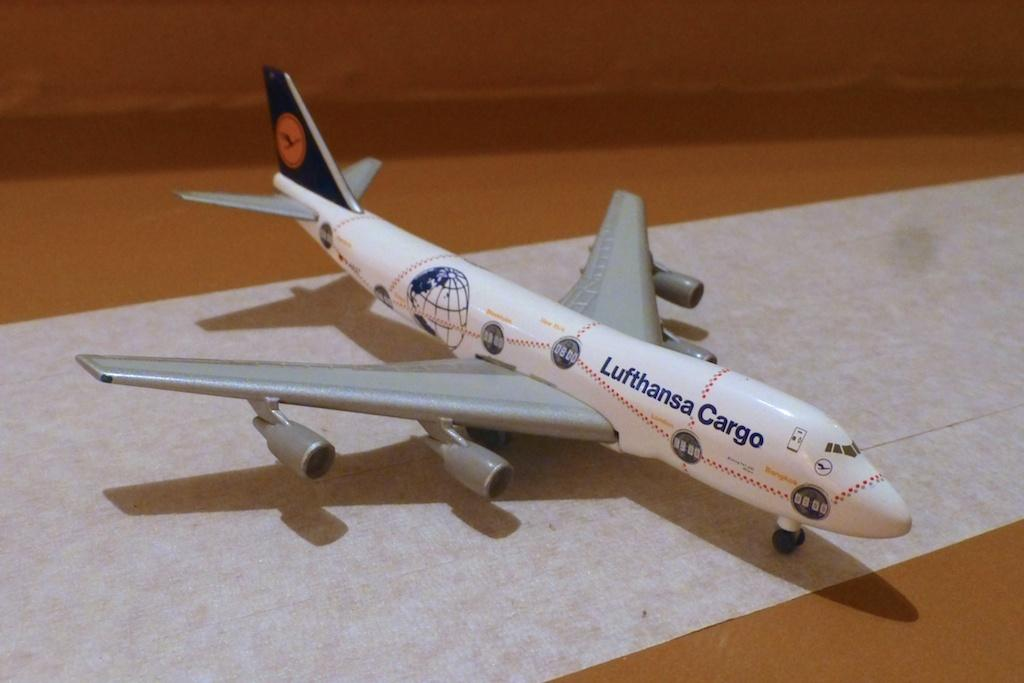<image>
Describe the image concisely. A small replica plane has Lufthansa Cargo on its fuselage. 